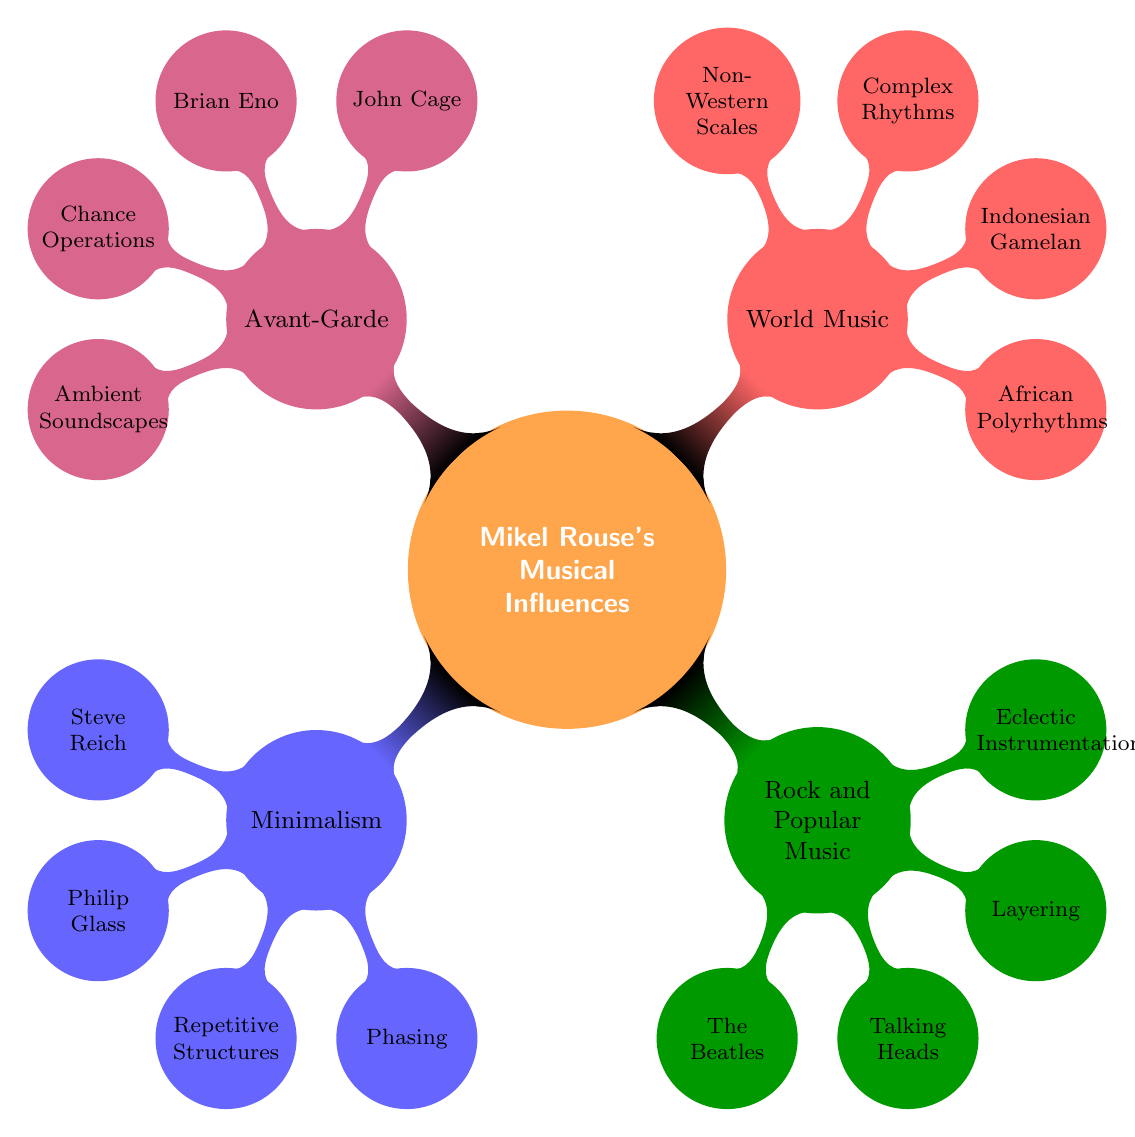What is the main topic of this mind map? The main topic is located at the center of the diagram and is explicitly labeled as "Exploration of Musical Influences on Mikel Rouse’s Work."
Answer: Exploration of Musical Influences on Mikel Rouse’s Work How many primary influence categories are present in the diagram? To find the number of primary influence categories, count the main branches directly connected to the central node. There are four branches: Minimalism, Rock and Popular Music, World Music, and Avant-Garde.
Answer: 4 Which artist is associated with Minimalism? In the Minimalism section, the influence node contains two artists. The first listed is Steve Reich.
Answer: Steve Reich What techniques are used in Rock and Popular Music? Under the Rock and Popular Music section, there are two techniques mentioned. Reading the nodes will reveal they are "Layering" and "Eclectic Instrumentation."
Answer: Layering, Eclectic Instrumentation Which musical influence relates to African Polyrhythms? The diagram shows that African Polyrhythms is listed under the World Music category, indicating its association.
Answer: World Music What technique is associated with John Cage? John Cage is listed under the Avant-Garde section, and the techniques associated with that section include "Chance Operations."
Answer: Chance Operations How many influences are listed under World Music? The World Music node reveals two influences: African Polyrhythms and Indonesian Gamelan. Counting these will give the answer.
Answer: 2 Which two artists are associated with the Avant-Garde category? Within the Avant-Garde section, there are two artists clearly labeled: John Cage and Brian Eno.
Answer: John Cage, Brian Eno Are there any techniques under the Minimalism category? Yes, the Minimalism node contains two techniques, explicitly mentioned as "Repetitive Structures" and "Phasing."
Answer: Yes, Repetitive Structures, Phasing 